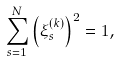Convert formula to latex. <formula><loc_0><loc_0><loc_500><loc_500>\sum _ { s = 1 } ^ { N } \left ( \xi _ { s } ^ { ( k ) } \right ) ^ { 2 } = 1 ,</formula> 